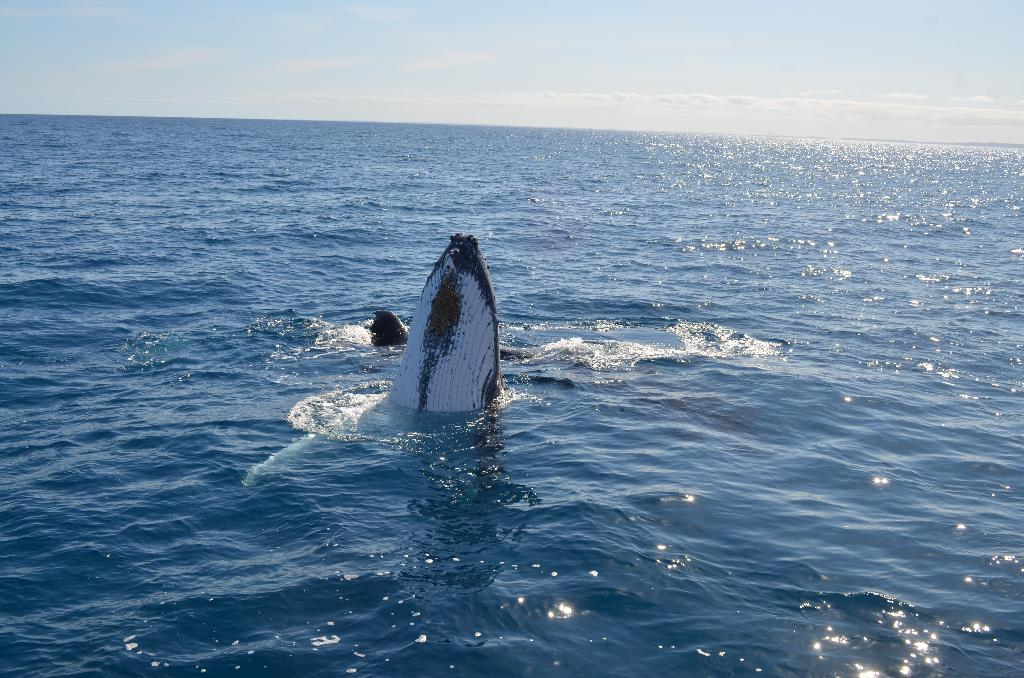What type of natural body of water is present in the image? There is an ocean in the image. What else can be seen in the image besides the ocean? The sky is visible at the top of the image. Is there any wildlife present in the ocean? Yes, there is an animal in the ocean. How does the kettle get kicked in the image? There is no kettle or kicking action present in the image. What type of thing is being kicked by the animal in the image? There is no kicking action or thing being kicked in the image; it only features an animal in the ocean. 